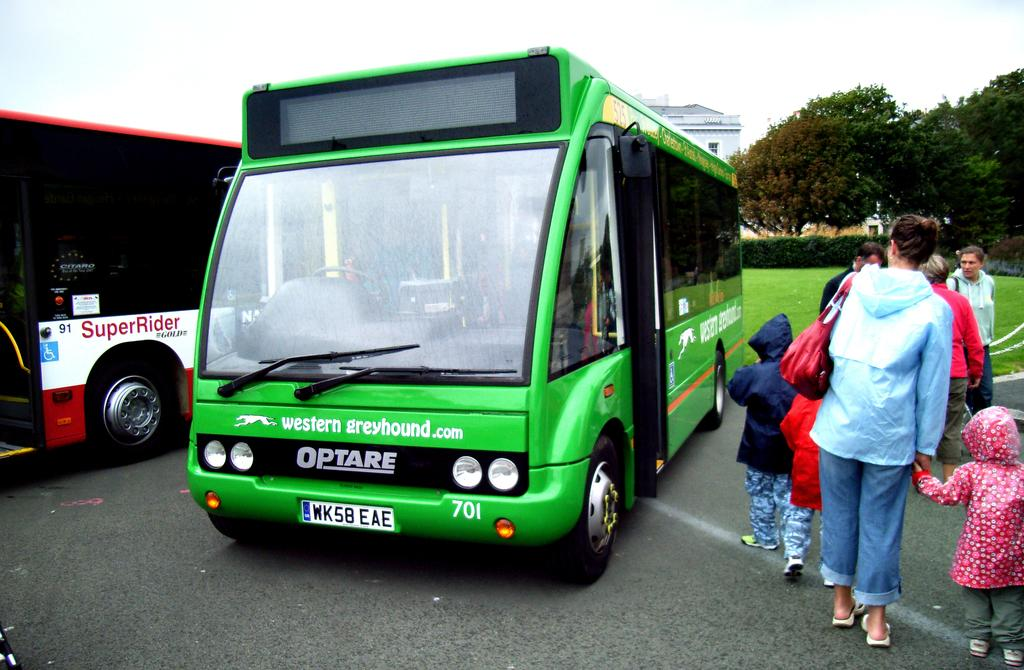What can be seen on the roadside in the image? There are vehicles on the roadside in the image. What are the people near the vehicles doing? There are people standing near the vehicles. What can be seen in the distance in the image? There are trees visible in the background of the image. What type of structure can be seen in the background? There is at least one building in the background of the image. What muscle is being stretched by the person in the image? There is no person stretching a muscle in the image; it only shows vehicles and people standing near them. How many points are visible on the building in the image? There is no building with points visible in the image; only one building is mentioned in the background. 